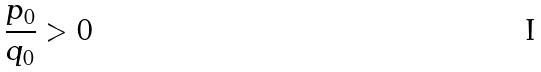<formula> <loc_0><loc_0><loc_500><loc_500>\frac { p _ { 0 } } { q _ { 0 } } > 0</formula> 